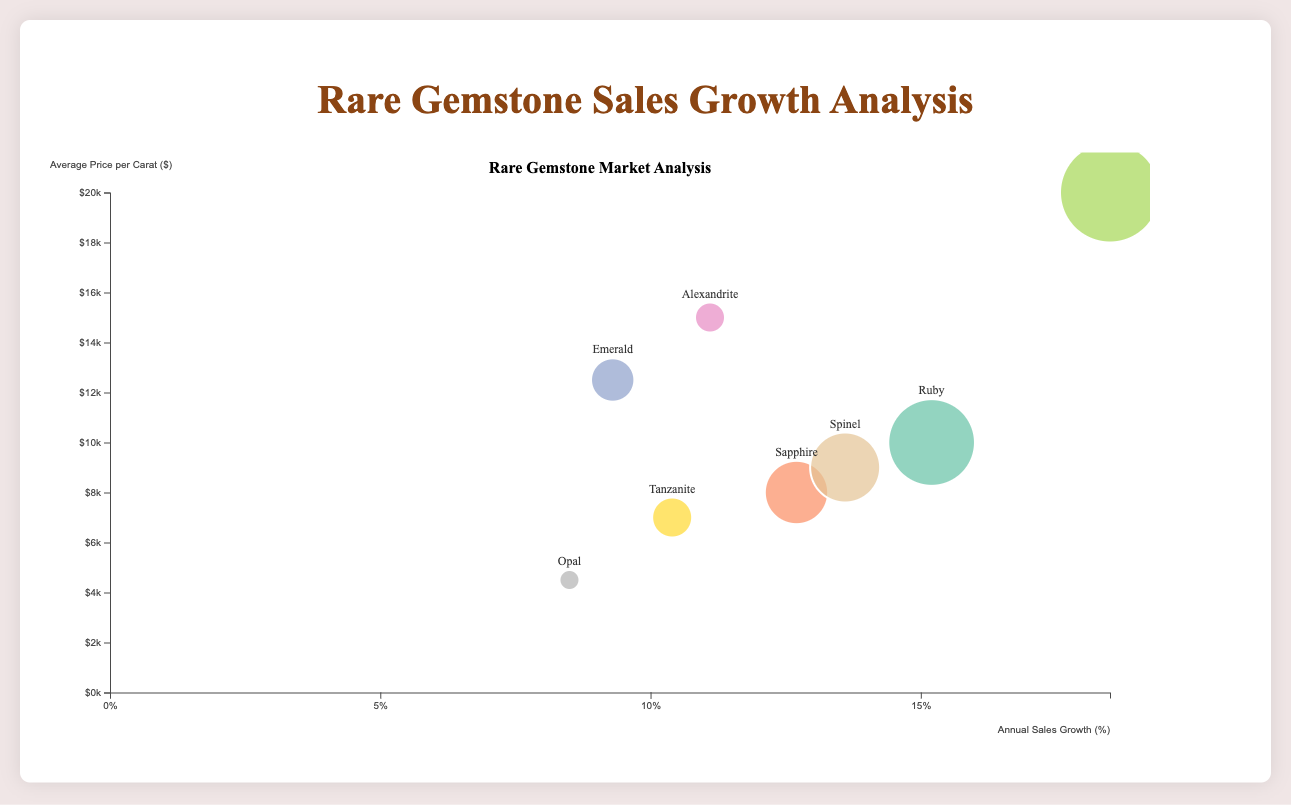What is the title of the chart? The title is displayed at the top center of the chart and reads "Rare Gemstone Sales Growth Analysis."
Answer: Rare Gemstone Sales Growth Analysis Which gemstone has the highest annual sales growth percentage? By examining the x-axis, which represents annual sales growth percentage, and the furthest point to the right, we can see that Paraiba Tourmaline has the highest growth at 18.5%.
Answer: Paraiba Tourmaline What is represented on the y-axis? Looking at the y-axis label, it indicates the "Average Price per Carat ($)."
Answer: Average Price per Carat ($) How many gemstones are represented in the bubble chart? Count the number of unique bubbles or gemstone labels in the chart. There are 8 gemstones represented.
Answer: 8 Which gemstone has the lowest market demand index? By comparing the size of the bubbles (the smallest bubble), we can deduce that Opal has the smallest size, indicating the lowest market demand index of 6.5.
Answer: Opal What is the average price per carat of the gemstone with the highest market demand index? Locate the largest bubble, representing Paraiba Tourmaline with a market demand index of 8.9, and check its position on the y-axis for the price, which is $20000 per carat.
Answer: $20000 Compare the annual sales growth percentage between Ruby and Sapphire. Ruby has an annual sales growth percentage of 15.2%, while Sapphire has 12.7%. Therefore, Ruby's growth is higher by 2.5%.
Answer: Ruby is higher by 2.5% Which gemstones lie below the $10,000 per carat mark? Check the y-axis positions and identify the bubbles below the $10,000 mark. These are Ruby, Sapphire, Tanzanite, Spinel, and Opal.
Answer: Ruby, Sapphire, Tanzanite, Spinel, Opal What visual feature is used to distinguish different gemstones? Each gemstone is represented by a different color, as seen by the varied bubble colors.
Answer: Color How does the average price per carat of Alexandrite compare to Spinel? Alexandrite has an average price per carat of $15000, while Spinel has $9000, making Alexandrite $6000 more expensive than Spinel.
Answer: $6000 more 